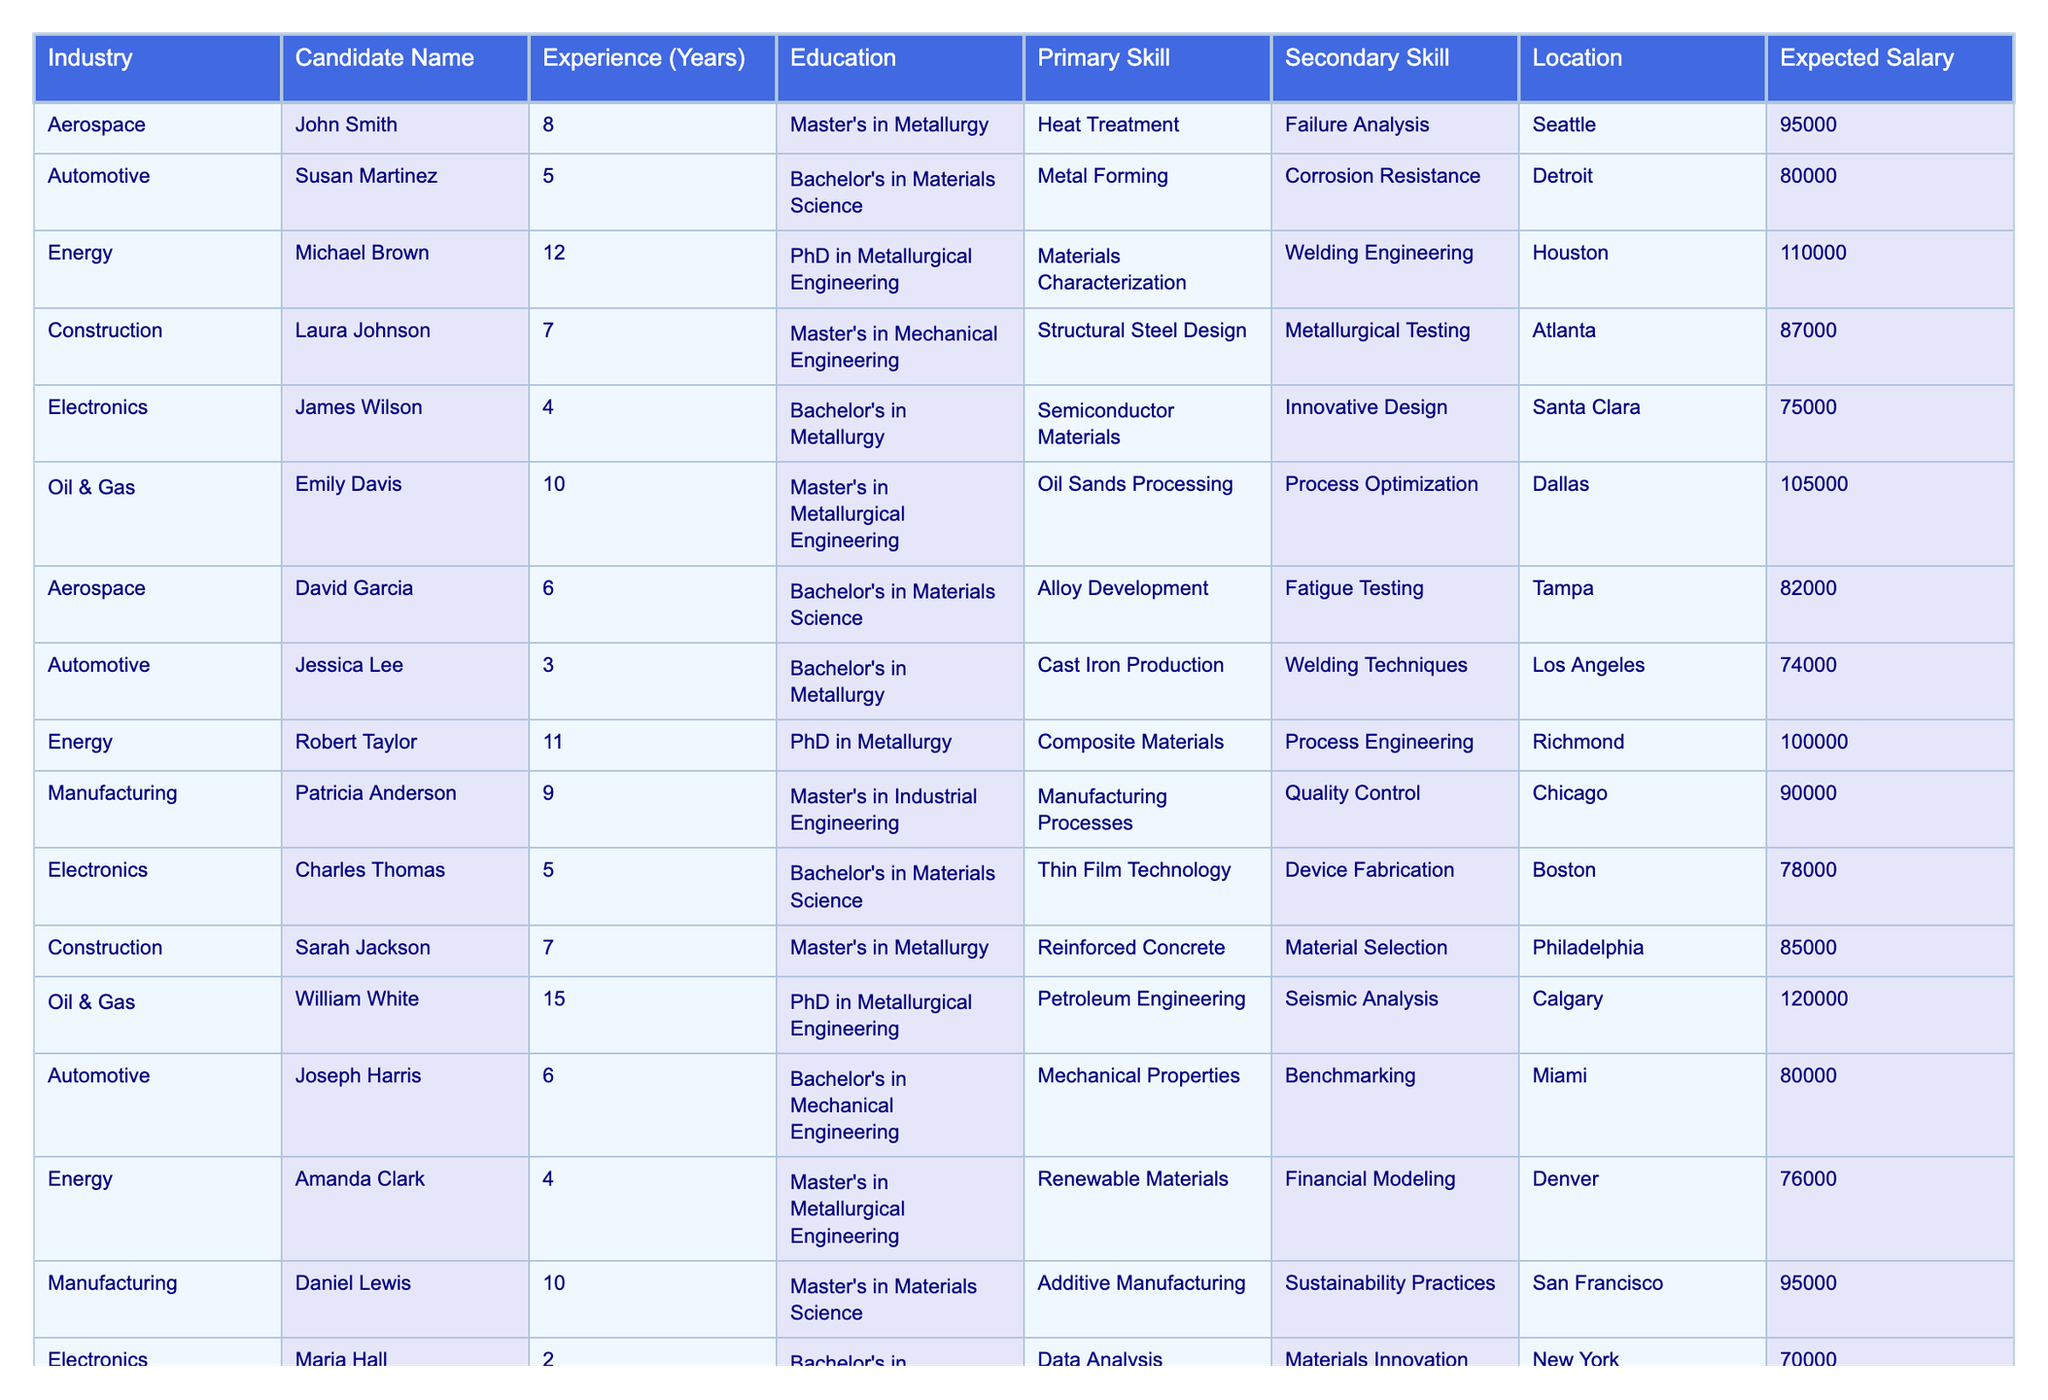What is the highest expected salary among the candidates? The table lists the expected salaries for all candidates. Scanning through the "Expected Salary" column, I find that the highest salary is 120000, which belongs to William White in the Oil & Gas industry.
Answer: 120000 Which candidate has the longest experience? By looking at the "Experience (Years)" column, I identify that William White has the most experience with 15 years.
Answer: 15 How many candidates have a PhD in their education? To find the number of candidates with a PhD, I review the "Education" column and count all entries that include "PhD". There are 4 candidates with a PhD.
Answer: 4 What is the average expected salary for candidates in the Aerospace industry? I look at the Aerospace candidates, whose expected salaries are 95000, 82000, and 97000. Their sum is (95000 + 82000 + 97000) = 274000, and there are 3 candidates, so the average is 274000/3 = 91333.33.
Answer: 91333.33 Which industry has the highest average expected salary? First, I calculate the average salaries for each industry: Aerospace (91333.33), Automotive (76000), Energy (108000), Construction (87000), Electronics (76500), Manufacturing (92500), Oil & Gas (115000). The highest average is found in the Oil & Gas industry at 115000.
Answer: Oil & Gas Is there any candidate located in Seattle? I check the "Location" column to see if any candidates list Seattle. I find that John Smith and Megan Young are both located in Seattle.
Answer: Yes What is the total experience of candidates in the Energy industry? The "Experience (Years)" for the Energy candidates are 12, 11, and 4. Adding these gives a total experience of (12 + 11 + 4) = 27 years in the Energy industry.
Answer: 27 Which candidate has the second highest expected salary and what is the amount? I look at the "Expected Salary" column and find the highest is 120000 (William White), and the next highest salary is 115000 (Rebecca King).
Answer: 115000 Are there any candidates from Electronics that have more than 5 years of experience? I check the "Electronics" entries and see that James Wilson has 4 years and Charles Thomas has 5 years, meaning neither exceeds 5 years of experience.
Answer: No What percentage of candidates have a Master's degree? I count the candidates with a Master's degree: John Smith, Laura Johnson, Oil & Gas candidates, and others, resulting in 7 Master’s out of 15 total candidates. This gives (7/15) * 100% = 46.67%.
Answer: 46.67% 